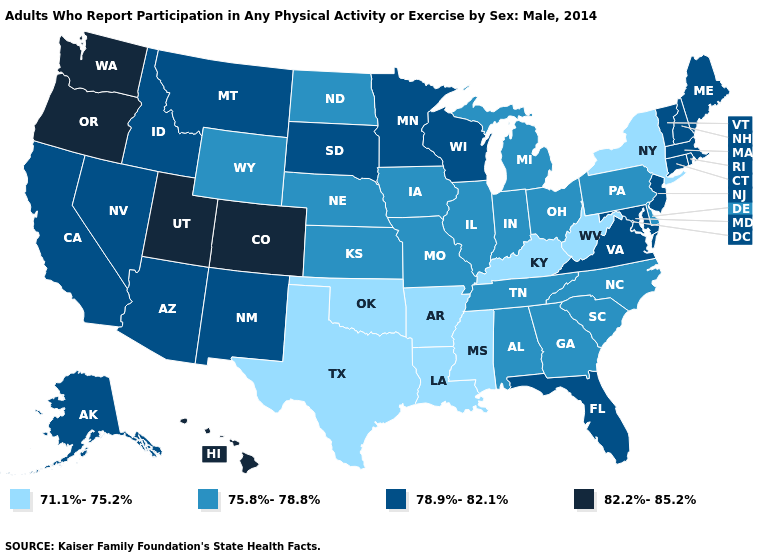Which states have the highest value in the USA?
Answer briefly. Colorado, Hawaii, Oregon, Utah, Washington. How many symbols are there in the legend?
Concise answer only. 4. What is the value of New York?
Answer briefly. 71.1%-75.2%. Name the states that have a value in the range 82.2%-85.2%?
Keep it brief. Colorado, Hawaii, Oregon, Utah, Washington. What is the lowest value in the USA?
Concise answer only. 71.1%-75.2%. What is the value of Idaho?
Short answer required. 78.9%-82.1%. Name the states that have a value in the range 82.2%-85.2%?
Answer briefly. Colorado, Hawaii, Oregon, Utah, Washington. What is the value of Ohio?
Quick response, please. 75.8%-78.8%. Name the states that have a value in the range 75.8%-78.8%?
Give a very brief answer. Alabama, Delaware, Georgia, Illinois, Indiana, Iowa, Kansas, Michigan, Missouri, Nebraska, North Carolina, North Dakota, Ohio, Pennsylvania, South Carolina, Tennessee, Wyoming. Name the states that have a value in the range 75.8%-78.8%?
Keep it brief. Alabama, Delaware, Georgia, Illinois, Indiana, Iowa, Kansas, Michigan, Missouri, Nebraska, North Carolina, North Dakota, Ohio, Pennsylvania, South Carolina, Tennessee, Wyoming. Among the states that border Florida , which have the lowest value?
Short answer required. Alabama, Georgia. Which states have the lowest value in the West?
Be succinct. Wyoming. Does Kansas have the same value as Arizona?
Give a very brief answer. No. Name the states that have a value in the range 82.2%-85.2%?
Keep it brief. Colorado, Hawaii, Oregon, Utah, Washington. Does the first symbol in the legend represent the smallest category?
Short answer required. Yes. 